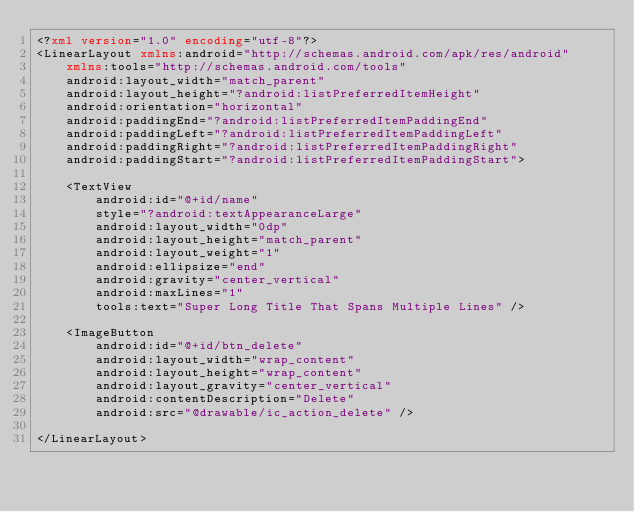<code> <loc_0><loc_0><loc_500><loc_500><_XML_><?xml version="1.0" encoding="utf-8"?>
<LinearLayout xmlns:android="http://schemas.android.com/apk/res/android"
    xmlns:tools="http://schemas.android.com/tools"
    android:layout_width="match_parent"
    android:layout_height="?android:listPreferredItemHeight"
    android:orientation="horizontal"
    android:paddingEnd="?android:listPreferredItemPaddingEnd"
    android:paddingLeft="?android:listPreferredItemPaddingLeft"
    android:paddingRight="?android:listPreferredItemPaddingRight"
    android:paddingStart="?android:listPreferredItemPaddingStart">

    <TextView
        android:id="@+id/name"
        style="?android:textAppearanceLarge"
        android:layout_width="0dp"
        android:layout_height="match_parent"
        android:layout_weight="1"
        android:ellipsize="end"
        android:gravity="center_vertical"
        android:maxLines="1"
        tools:text="Super Long Title That Spans Multiple Lines" />

    <ImageButton
        android:id="@+id/btn_delete"
        android:layout_width="wrap_content"
        android:layout_height="wrap_content"
        android:layout_gravity="center_vertical"
        android:contentDescription="Delete"
        android:src="@drawable/ic_action_delete" />

</LinearLayout></code> 